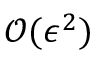Convert formula to latex. <formula><loc_0><loc_0><loc_500><loc_500>\mathcal { O } ( \epsilon ^ { 2 } )</formula> 